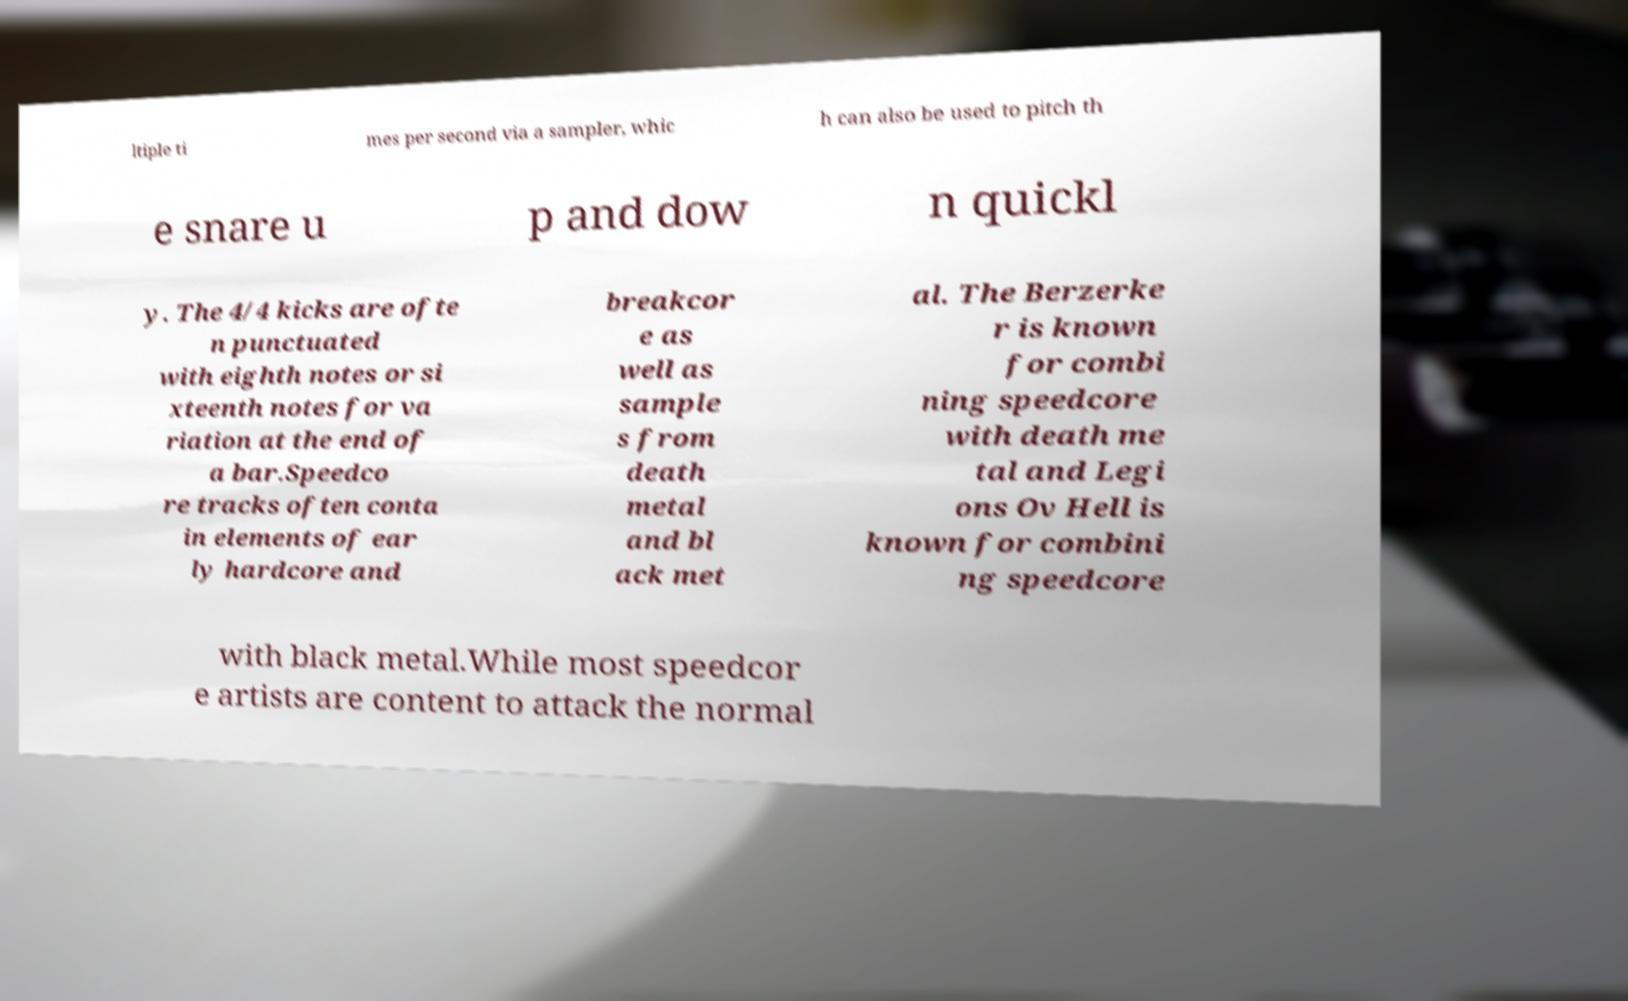I need the written content from this picture converted into text. Can you do that? ltiple ti mes per second via a sampler, whic h can also be used to pitch th e snare u p and dow n quickl y. The 4/4 kicks are ofte n punctuated with eighth notes or si xteenth notes for va riation at the end of a bar.Speedco re tracks often conta in elements of ear ly hardcore and breakcor e as well as sample s from death metal and bl ack met al. The Berzerke r is known for combi ning speedcore with death me tal and Legi ons Ov Hell is known for combini ng speedcore with black metal.While most speedcor e artists are content to attack the normal 